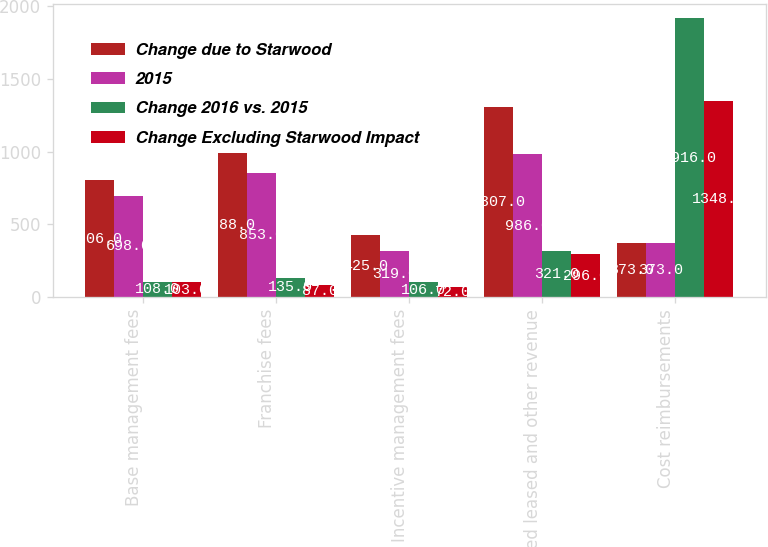<chart> <loc_0><loc_0><loc_500><loc_500><stacked_bar_chart><ecel><fcel>Base management fees<fcel>Franchise fees<fcel>Incentive management fees<fcel>Owned leased and other revenue<fcel>Cost reimbursements<nl><fcel>Change due to Starwood<fcel>806<fcel>988<fcel>425<fcel>1307<fcel>373<nl><fcel>2015<fcel>698<fcel>853<fcel>319<fcel>986<fcel>373<nl><fcel>Change 2016 vs. 2015<fcel>108<fcel>135<fcel>106<fcel>321<fcel>1916<nl><fcel>Change Excluding Starwood Impact<fcel>103<fcel>87<fcel>72<fcel>296<fcel>1348<nl></chart> 